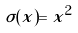<formula> <loc_0><loc_0><loc_500><loc_500>\sigma ( x ) = x ^ { 2 }</formula> 